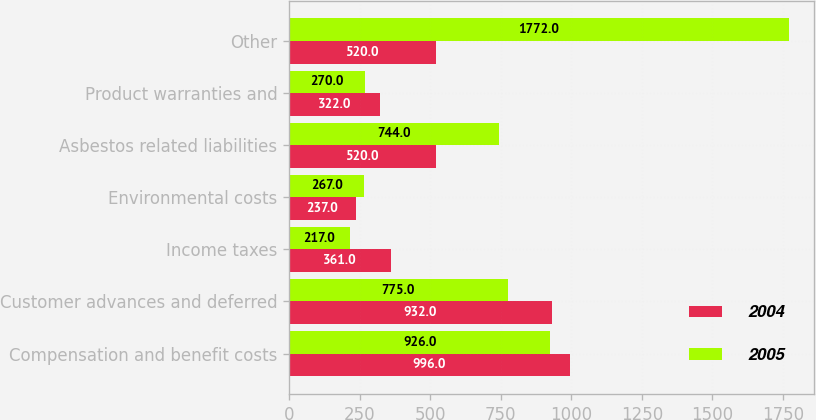<chart> <loc_0><loc_0><loc_500><loc_500><stacked_bar_chart><ecel><fcel>Compensation and benefit costs<fcel>Customer advances and deferred<fcel>Income taxes<fcel>Environmental costs<fcel>Asbestos related liabilities<fcel>Product warranties and<fcel>Other<nl><fcel>2004<fcel>996<fcel>932<fcel>361<fcel>237<fcel>520<fcel>322<fcel>520<nl><fcel>2005<fcel>926<fcel>775<fcel>217<fcel>267<fcel>744<fcel>270<fcel>1772<nl></chart> 